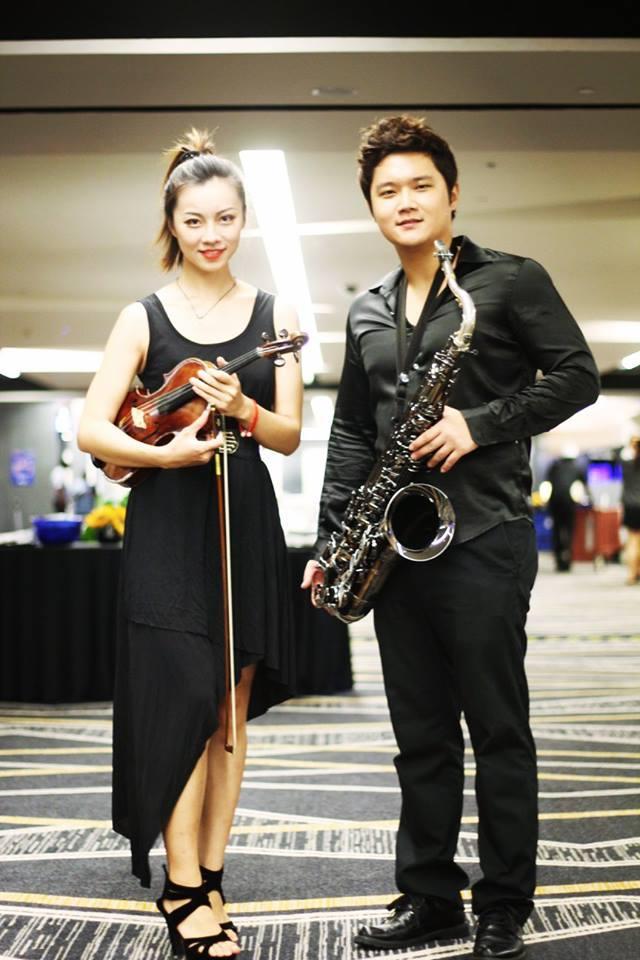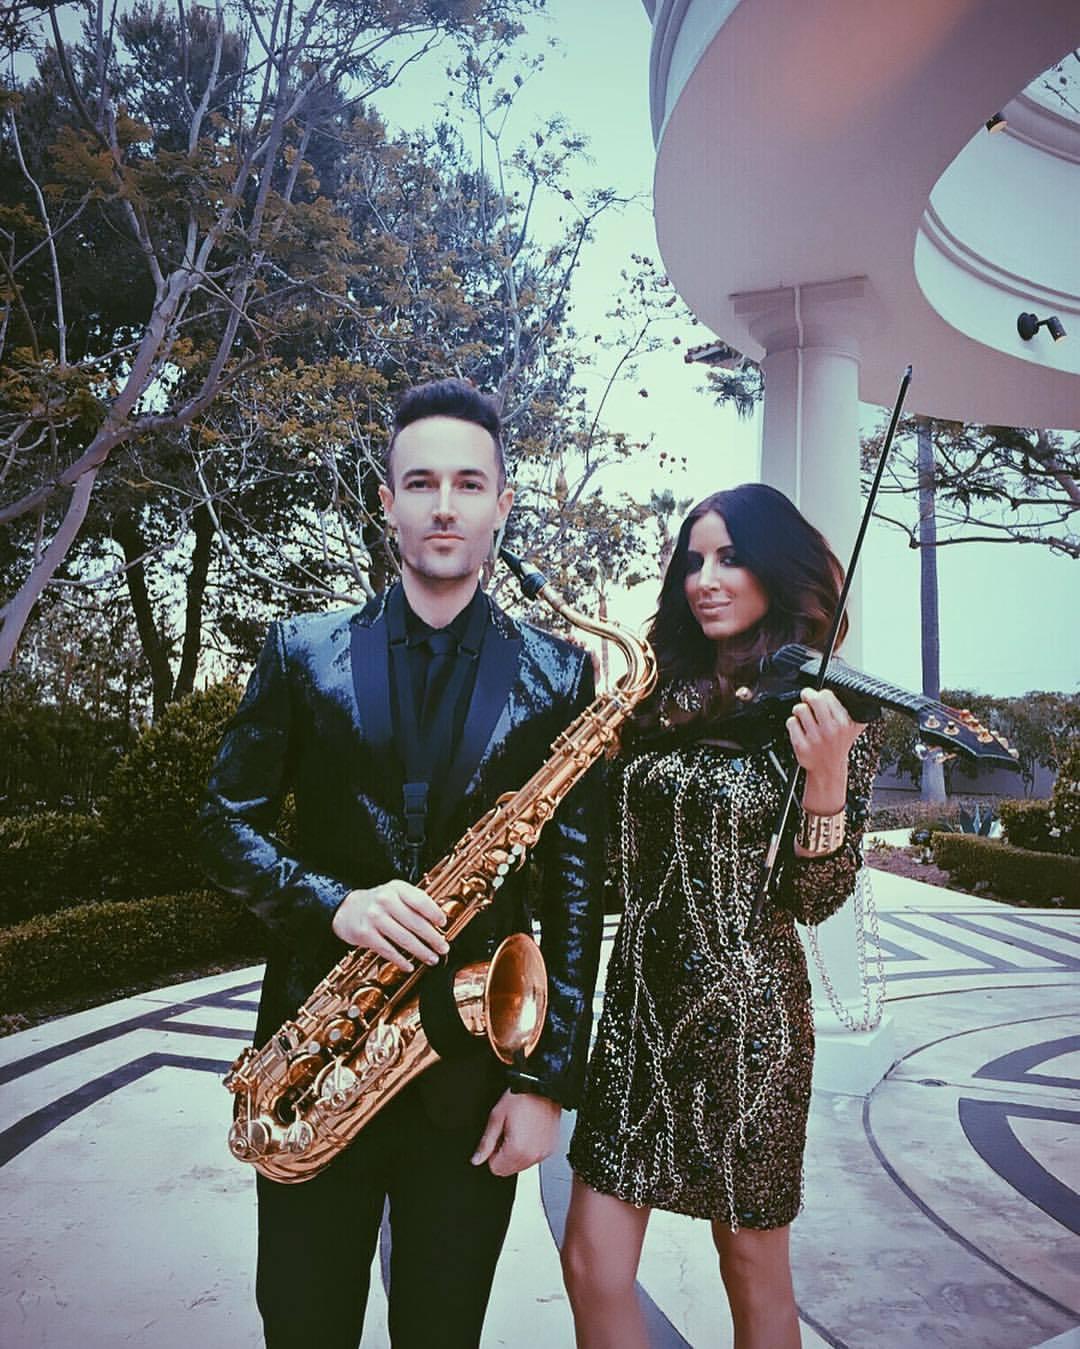The first image is the image on the left, the second image is the image on the right. Evaluate the accuracy of this statement regarding the images: "There are no more than three people in the pair of images.". Is it true? Answer yes or no. No. The first image is the image on the left, the second image is the image on the right. Considering the images on both sides, is "At least one woman appears to be actively playing a saxophone." valid? Answer yes or no. No. 